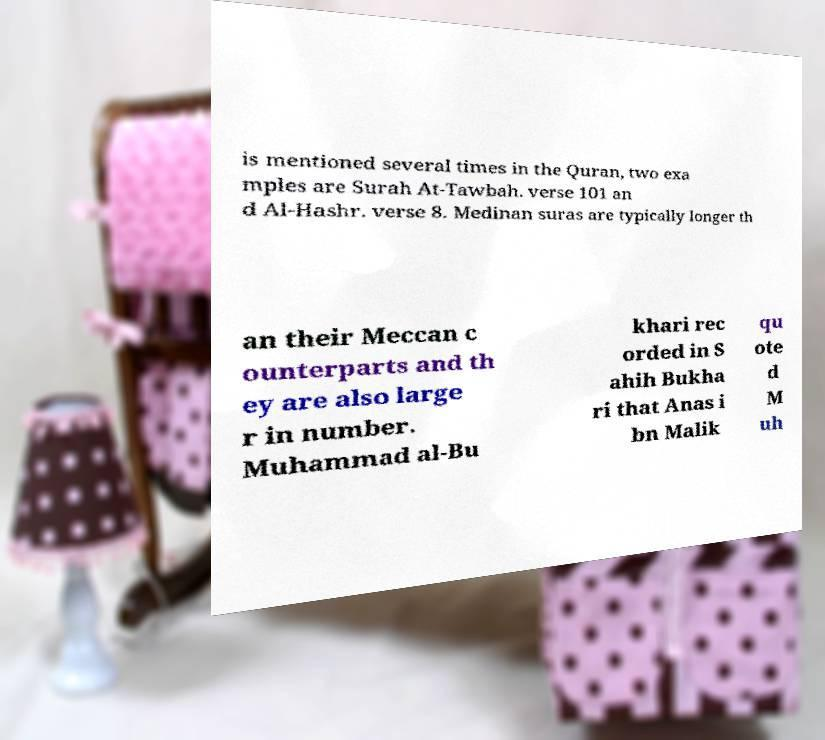Please identify and transcribe the text found in this image. is mentioned several times in the Quran, two exa mples are Surah At-Tawbah. verse 101 an d Al-Hashr. verse 8. Medinan suras are typically longer th an their Meccan c ounterparts and th ey are also large r in number. Muhammad al-Bu khari rec orded in S ahih Bukha ri that Anas i bn Malik qu ote d M uh 